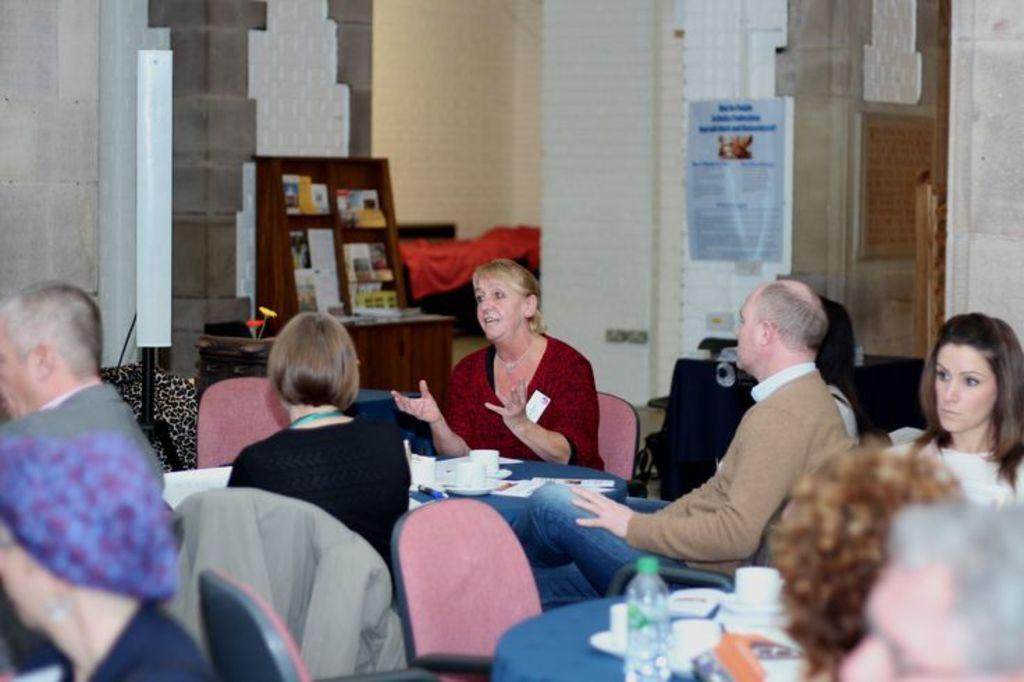What color is the wall in the image? The wall in the image is white. What is on the wall in the image? There is a poster on the wall. What are the people in the image doing? The people are sitting on chairs in the image. What furniture is present in the image? There is a table in the image. What objects are on the table in the image? There is a cup, saucers, and papers on the table. How many wrens are sitting on the table in the image? There are no wrens present in the image; it only features a table with a cup, saucers, and papers. 